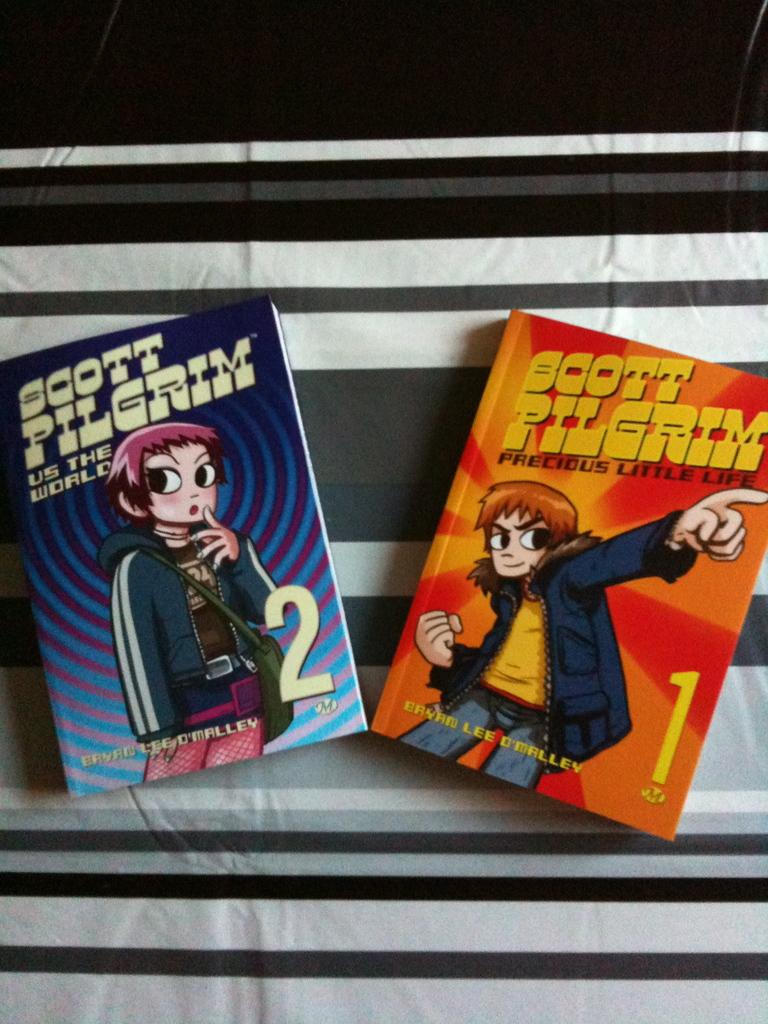<image>
Give a short and clear explanation of the subsequent image. Two books with titles by Scott Pilgrim laying on a table side by side. 